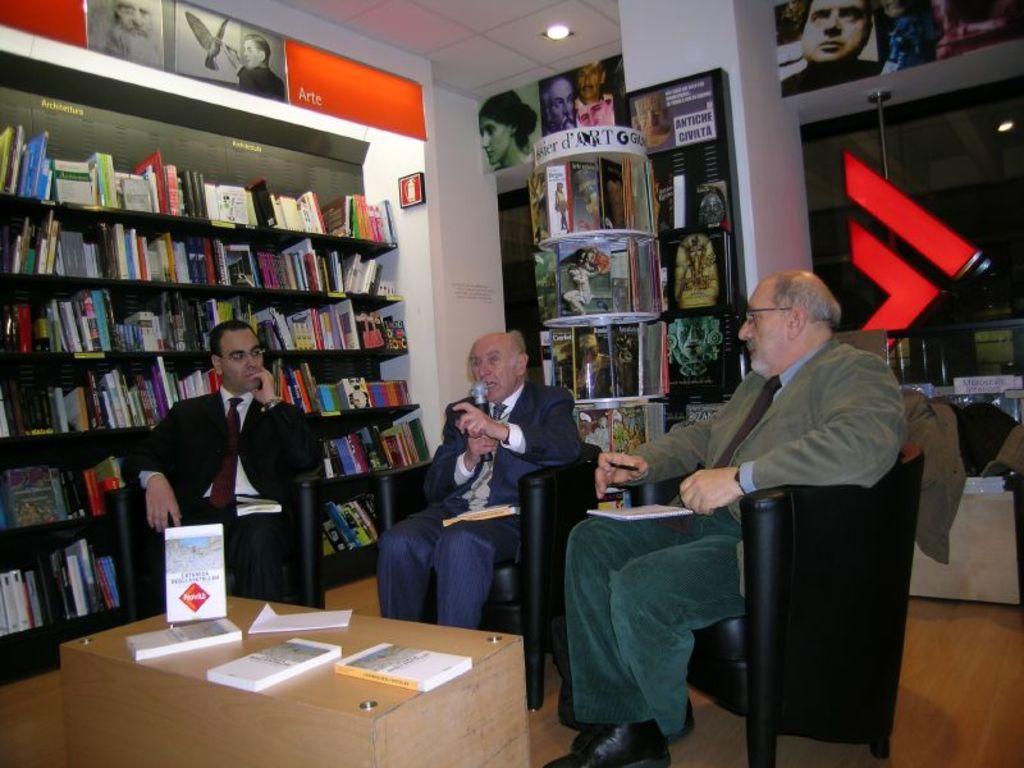Describe this image in one or two sentences. The three people sitting on a chair. There is a table. There is a book on a table. We can see the background there is a cupboard,poster. In the center we have a person. He's holding a mic. 